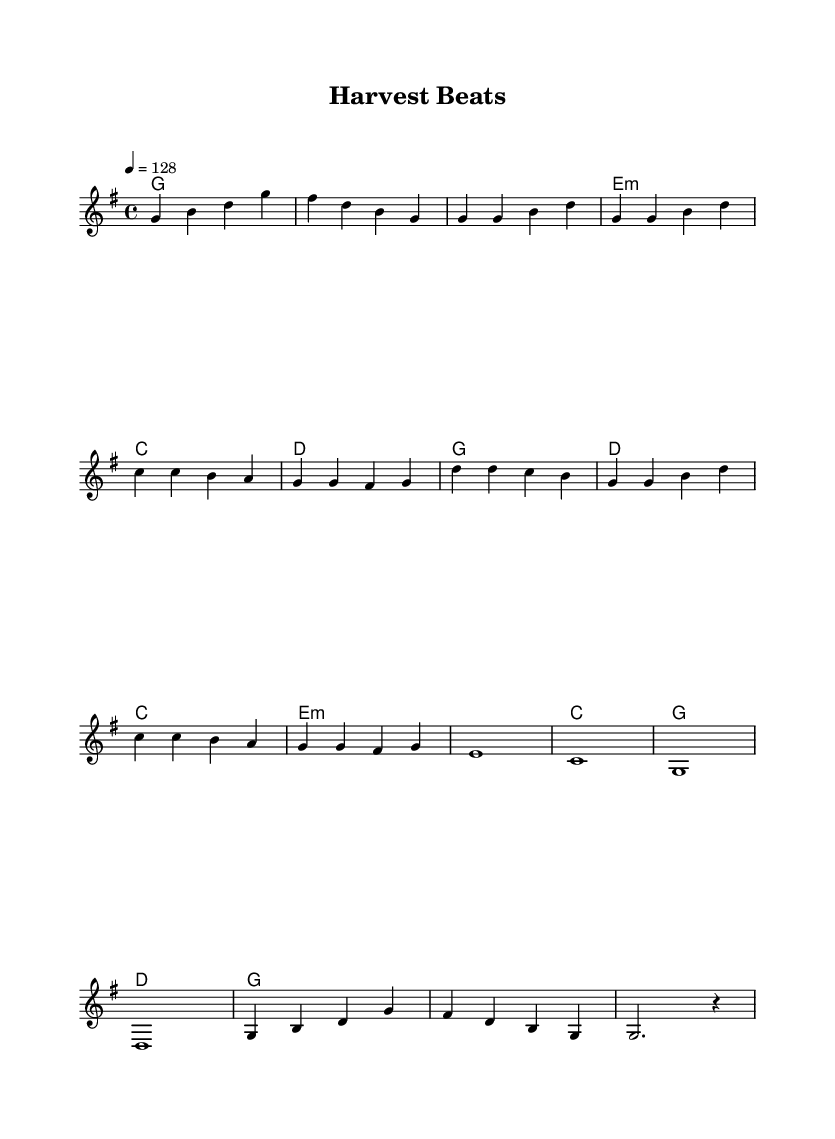What is the key signature of this music? The key signature is G major, which has one sharp (F#). This can be determined from the beginning of the score where the key signature is indicated.
Answer: G major What is the time signature of this music? The time signature is 4/4, indicated at the start of the score. This means there are four beats per measure, and a quarter note receives one beat.
Answer: 4/4 What is the tempo marking for this piece? The tempo marking is 128 beats per minute, specified in the score at the beginning with the instruction "4 = 128". This indicates the speed at which the piece should be played.
Answer: 128 How many measures are there in the melody? The melody consists of 16 measures. This can be counted by assessing each vertical line (bar line) that divides the music into measures.
Answer: 16 What chord follows the first intro measure? The chord following the first intro measure is G major, which can be found in the harmonic section where it shows one chord that corresponds to each measure in the score.
Answer: G major What is the structure of the music? The structure consists of an Intro, Verse, Chorus, Bridge, and Outro. This is determined by the labeling in the melodies and harmonies indicating distinct sections of the song.
Answer: Intro, Verse, Chorus, Bridge, Outro 